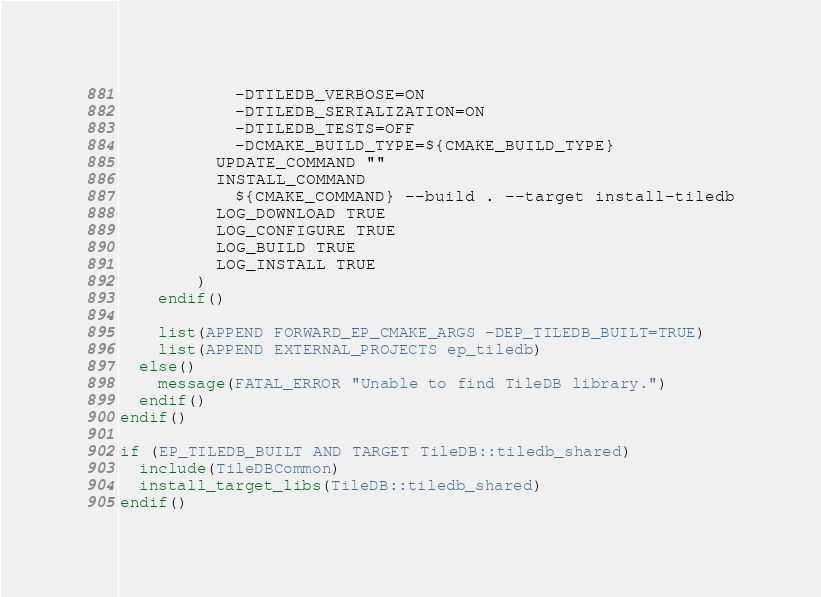<code> <loc_0><loc_0><loc_500><loc_500><_CMake_>            -DTILEDB_VERBOSE=ON
            -DTILEDB_SERIALIZATION=ON
            -DTILEDB_TESTS=OFF
            -DCMAKE_BUILD_TYPE=${CMAKE_BUILD_TYPE}
          UPDATE_COMMAND ""
          INSTALL_COMMAND
            ${CMAKE_COMMAND} --build . --target install-tiledb
          LOG_DOWNLOAD TRUE
          LOG_CONFIGURE TRUE
          LOG_BUILD TRUE
          LOG_INSTALL TRUE
        )
    endif()

    list(APPEND FORWARD_EP_CMAKE_ARGS -DEP_TILEDB_BUILT=TRUE)
    list(APPEND EXTERNAL_PROJECTS ep_tiledb)
  else()
    message(FATAL_ERROR "Unable to find TileDB library.")
  endif()
endif()

if (EP_TILEDB_BUILT AND TARGET TileDB::tiledb_shared)
  include(TileDBCommon)
  install_target_libs(TileDB::tiledb_shared)
endif()
</code> 